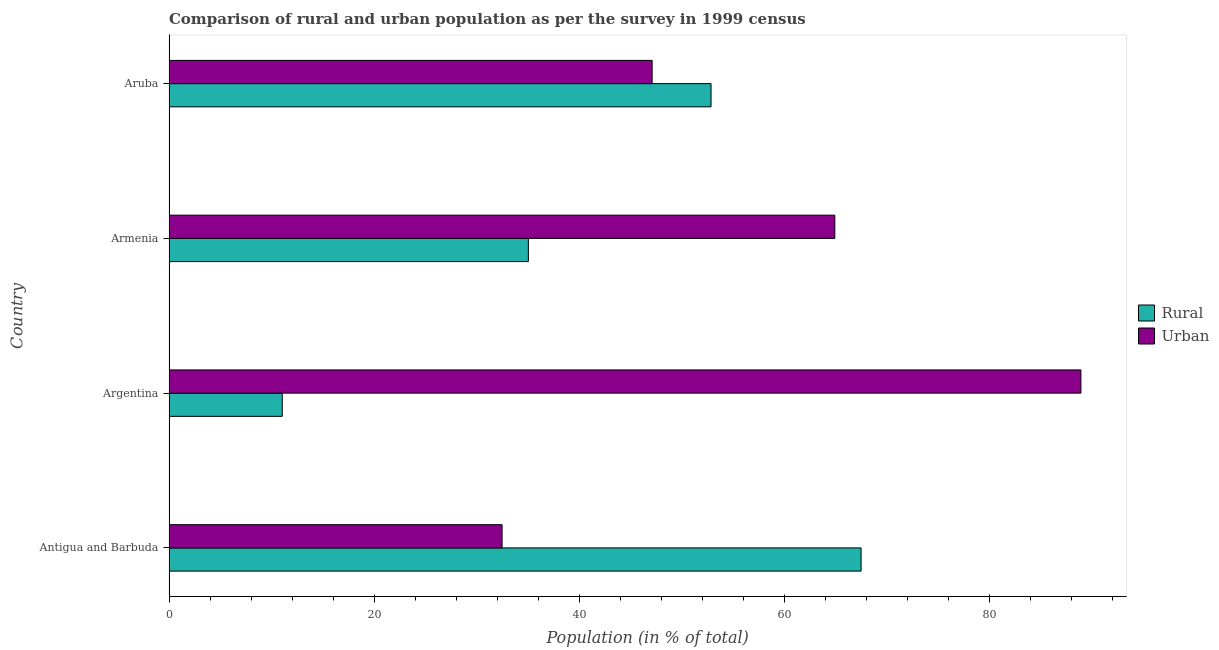How many different coloured bars are there?
Offer a very short reply. 2. How many groups of bars are there?
Offer a terse response. 4. Are the number of bars per tick equal to the number of legend labels?
Keep it short and to the point. Yes. What is the label of the 3rd group of bars from the top?
Keep it short and to the point. Argentina. In how many cases, is the number of bars for a given country not equal to the number of legend labels?
Give a very brief answer. 0. What is the urban population in Aruba?
Your answer should be compact. 47.13. Across all countries, what is the maximum urban population?
Your response must be concise. 88.95. Across all countries, what is the minimum urban population?
Ensure brevity in your answer.  32.49. In which country was the rural population maximum?
Provide a short and direct response. Antigua and Barbuda. In which country was the rural population minimum?
Make the answer very short. Argentina. What is the total urban population in the graph?
Make the answer very short. 233.52. What is the difference between the rural population in Antigua and Barbuda and that in Armenia?
Keep it short and to the point. 32.46. What is the difference between the rural population in Argentina and the urban population in Armenia?
Your answer should be very brief. -53.9. What is the average urban population per country?
Offer a very short reply. 58.38. What is the difference between the urban population and rural population in Armenia?
Provide a succinct answer. 29.89. In how many countries, is the urban population greater than 48 %?
Offer a terse response. 2. What is the ratio of the rural population in Armenia to that in Aruba?
Offer a very short reply. 0.66. Is the urban population in Argentina less than that in Armenia?
Ensure brevity in your answer.  No. Is the difference between the urban population in Argentina and Aruba greater than the difference between the rural population in Argentina and Aruba?
Give a very brief answer. Yes. What is the difference between the highest and the second highest rural population?
Ensure brevity in your answer.  14.64. What is the difference between the highest and the lowest rural population?
Provide a succinct answer. 56.46. In how many countries, is the urban population greater than the average urban population taken over all countries?
Your answer should be compact. 2. What does the 1st bar from the top in Aruba represents?
Your answer should be very brief. Urban. What does the 1st bar from the bottom in Antigua and Barbuda represents?
Provide a short and direct response. Rural. How many bars are there?
Give a very brief answer. 8. How many countries are there in the graph?
Provide a succinct answer. 4. Does the graph contain grids?
Your response must be concise. No. Where does the legend appear in the graph?
Give a very brief answer. Center right. What is the title of the graph?
Make the answer very short. Comparison of rural and urban population as per the survey in 1999 census. Does "Tetanus" appear as one of the legend labels in the graph?
Your response must be concise. No. What is the label or title of the X-axis?
Make the answer very short. Population (in % of total). What is the label or title of the Y-axis?
Your answer should be compact. Country. What is the Population (in % of total) in Rural in Antigua and Barbuda?
Ensure brevity in your answer.  67.51. What is the Population (in % of total) of Urban in Antigua and Barbuda?
Give a very brief answer. 32.49. What is the Population (in % of total) in Rural in Argentina?
Provide a short and direct response. 11.05. What is the Population (in % of total) in Urban in Argentina?
Keep it short and to the point. 88.95. What is the Population (in % of total) of Rural in Armenia?
Provide a succinct answer. 35.05. What is the Population (in % of total) of Urban in Armenia?
Ensure brevity in your answer.  64.95. What is the Population (in % of total) in Rural in Aruba?
Offer a terse response. 52.87. What is the Population (in % of total) of Urban in Aruba?
Offer a very short reply. 47.13. Across all countries, what is the maximum Population (in % of total) of Rural?
Your answer should be compact. 67.51. Across all countries, what is the maximum Population (in % of total) in Urban?
Your answer should be very brief. 88.95. Across all countries, what is the minimum Population (in % of total) of Rural?
Your answer should be very brief. 11.05. Across all countries, what is the minimum Population (in % of total) in Urban?
Your answer should be very brief. 32.49. What is the total Population (in % of total) in Rural in the graph?
Keep it short and to the point. 166.48. What is the total Population (in % of total) of Urban in the graph?
Give a very brief answer. 233.52. What is the difference between the Population (in % of total) in Rural in Antigua and Barbuda and that in Argentina?
Provide a succinct answer. 56.46. What is the difference between the Population (in % of total) in Urban in Antigua and Barbuda and that in Argentina?
Your answer should be very brief. -56.46. What is the difference between the Population (in % of total) in Rural in Antigua and Barbuda and that in Armenia?
Offer a very short reply. 32.46. What is the difference between the Population (in % of total) in Urban in Antigua and Barbuda and that in Armenia?
Provide a succinct answer. -32.46. What is the difference between the Population (in % of total) in Rural in Antigua and Barbuda and that in Aruba?
Make the answer very short. 14.64. What is the difference between the Population (in % of total) of Urban in Antigua and Barbuda and that in Aruba?
Your answer should be very brief. -14.64. What is the difference between the Population (in % of total) in Rural in Argentina and that in Armenia?
Give a very brief answer. -24. What is the difference between the Population (in % of total) in Urban in Argentina and that in Armenia?
Offer a terse response. 24. What is the difference between the Population (in % of total) in Rural in Argentina and that in Aruba?
Keep it short and to the point. -41.83. What is the difference between the Population (in % of total) of Urban in Argentina and that in Aruba?
Keep it short and to the point. 41.83. What is the difference between the Population (in % of total) in Rural in Armenia and that in Aruba?
Your answer should be very brief. -17.82. What is the difference between the Population (in % of total) in Urban in Armenia and that in Aruba?
Provide a succinct answer. 17.82. What is the difference between the Population (in % of total) of Rural in Antigua and Barbuda and the Population (in % of total) of Urban in Argentina?
Give a very brief answer. -21.44. What is the difference between the Population (in % of total) of Rural in Antigua and Barbuda and the Population (in % of total) of Urban in Armenia?
Your answer should be compact. 2.56. What is the difference between the Population (in % of total) of Rural in Antigua and Barbuda and the Population (in % of total) of Urban in Aruba?
Your answer should be very brief. 20.38. What is the difference between the Population (in % of total) of Rural in Argentina and the Population (in % of total) of Urban in Armenia?
Keep it short and to the point. -53.9. What is the difference between the Population (in % of total) in Rural in Argentina and the Population (in % of total) in Urban in Aruba?
Keep it short and to the point. -36.08. What is the difference between the Population (in % of total) in Rural in Armenia and the Population (in % of total) in Urban in Aruba?
Offer a very short reply. -12.07. What is the average Population (in % of total) in Rural per country?
Offer a terse response. 41.62. What is the average Population (in % of total) of Urban per country?
Offer a very short reply. 58.38. What is the difference between the Population (in % of total) in Rural and Population (in % of total) in Urban in Antigua and Barbuda?
Your answer should be compact. 35.02. What is the difference between the Population (in % of total) of Rural and Population (in % of total) of Urban in Argentina?
Provide a succinct answer. -77.9. What is the difference between the Population (in % of total) of Rural and Population (in % of total) of Urban in Armenia?
Your answer should be compact. -29.89. What is the difference between the Population (in % of total) in Rural and Population (in % of total) in Urban in Aruba?
Make the answer very short. 5.75. What is the ratio of the Population (in % of total) of Rural in Antigua and Barbuda to that in Argentina?
Offer a very short reply. 6.11. What is the ratio of the Population (in % of total) of Urban in Antigua and Barbuda to that in Argentina?
Ensure brevity in your answer.  0.37. What is the ratio of the Population (in % of total) of Rural in Antigua and Barbuda to that in Armenia?
Give a very brief answer. 1.93. What is the ratio of the Population (in % of total) of Urban in Antigua and Barbuda to that in Armenia?
Ensure brevity in your answer.  0.5. What is the ratio of the Population (in % of total) in Rural in Antigua and Barbuda to that in Aruba?
Offer a very short reply. 1.28. What is the ratio of the Population (in % of total) in Urban in Antigua and Barbuda to that in Aruba?
Ensure brevity in your answer.  0.69. What is the ratio of the Population (in % of total) of Rural in Argentina to that in Armenia?
Ensure brevity in your answer.  0.32. What is the ratio of the Population (in % of total) in Urban in Argentina to that in Armenia?
Provide a short and direct response. 1.37. What is the ratio of the Population (in % of total) of Rural in Argentina to that in Aruba?
Offer a very short reply. 0.21. What is the ratio of the Population (in % of total) of Urban in Argentina to that in Aruba?
Offer a very short reply. 1.89. What is the ratio of the Population (in % of total) of Rural in Armenia to that in Aruba?
Ensure brevity in your answer.  0.66. What is the ratio of the Population (in % of total) of Urban in Armenia to that in Aruba?
Make the answer very short. 1.38. What is the difference between the highest and the second highest Population (in % of total) in Rural?
Give a very brief answer. 14.64. What is the difference between the highest and the second highest Population (in % of total) in Urban?
Make the answer very short. 24. What is the difference between the highest and the lowest Population (in % of total) of Rural?
Keep it short and to the point. 56.46. What is the difference between the highest and the lowest Population (in % of total) in Urban?
Offer a very short reply. 56.46. 